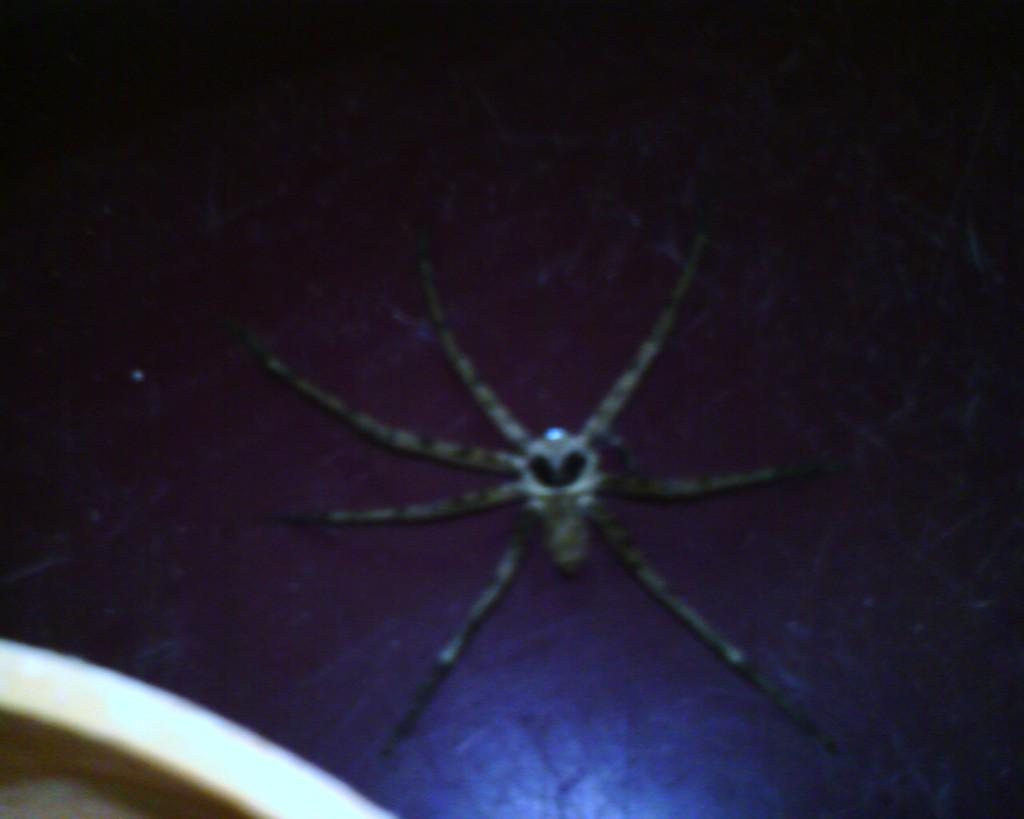Could you give a brief overview of what you see in this image? Background portion of the picture is dark. On the dark surface we can see a spider. In the bottom left corner of the picture we can see an object. 